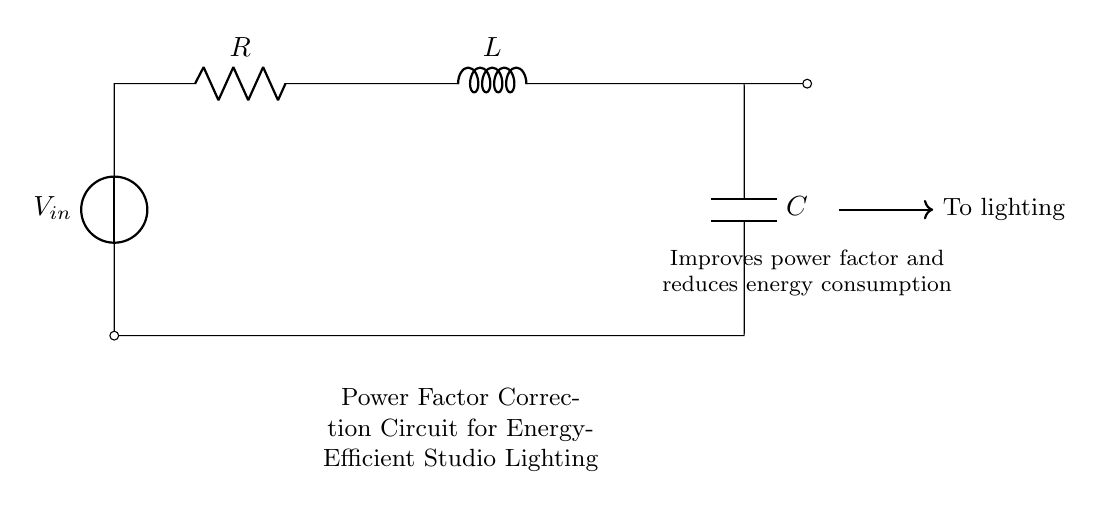What components are present in this circuit? The circuit diagram clearly shows a voltage source, a resistor, an inductor, and a capacitor. These components are denoted as V in, R, L, and C respectively.
Answer: Voltage source, resistor, inductor, capacitor What is the purpose of the power factor correction circuit? The label in the circuit notes that the purpose is to improve the power factor and reduce energy consumption. This indicates that the circuit is designed to optimize the performance of the lighting system by regulating the phase difference between voltage and current.
Answer: Improve power factor and reduce energy consumption How many components are connected in series in this circuit? The circuit diagram illustrates that the voltage source, resistor, and inductor are connected in series; the capacitor is connected to the node after the inductor. Counting these gives three components in series before the capacitor.
Answer: Three What is the role of the capacitor in this circuit? The capacitor in the circuit helps with power factor correction by compensating for the inductive load created by the inductor. It stores electrical energy temporarily and releases it, which helps balance the current and maintain an efficient power factor in the lighting system.
Answer: Compensate for inductive load What is the expected output of this circuit to the lighting system? The circuit includes an output arrow directed towards the lighting, indicating that the output is meant to supply the improved, energy-efficient AC power to the studio's lighting system. The improvements in the power factor suggest that this output will result in reduced energy waste and increased efficiency.
Answer: Improved AC power 